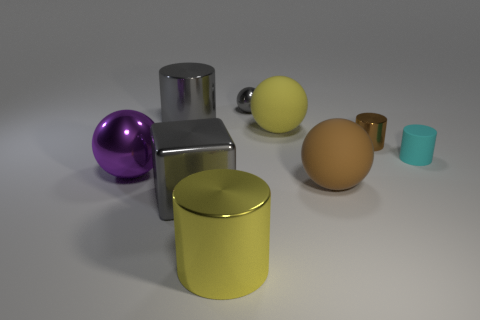Subtract all tiny cyan matte cylinders. How many cylinders are left? 3 Subtract all gray balls. How many balls are left? 3 Subtract 2 cylinders. How many cylinders are left? 2 Subtract all brown balls. Subtract all large yellow metallic cylinders. How many objects are left? 7 Add 2 purple objects. How many purple objects are left? 3 Add 7 large cyan metallic blocks. How many large cyan metallic blocks exist? 7 Add 1 rubber cylinders. How many objects exist? 10 Subtract 0 purple cylinders. How many objects are left? 9 Subtract all cylinders. How many objects are left? 5 Subtract all green cylinders. Subtract all green spheres. How many cylinders are left? 4 